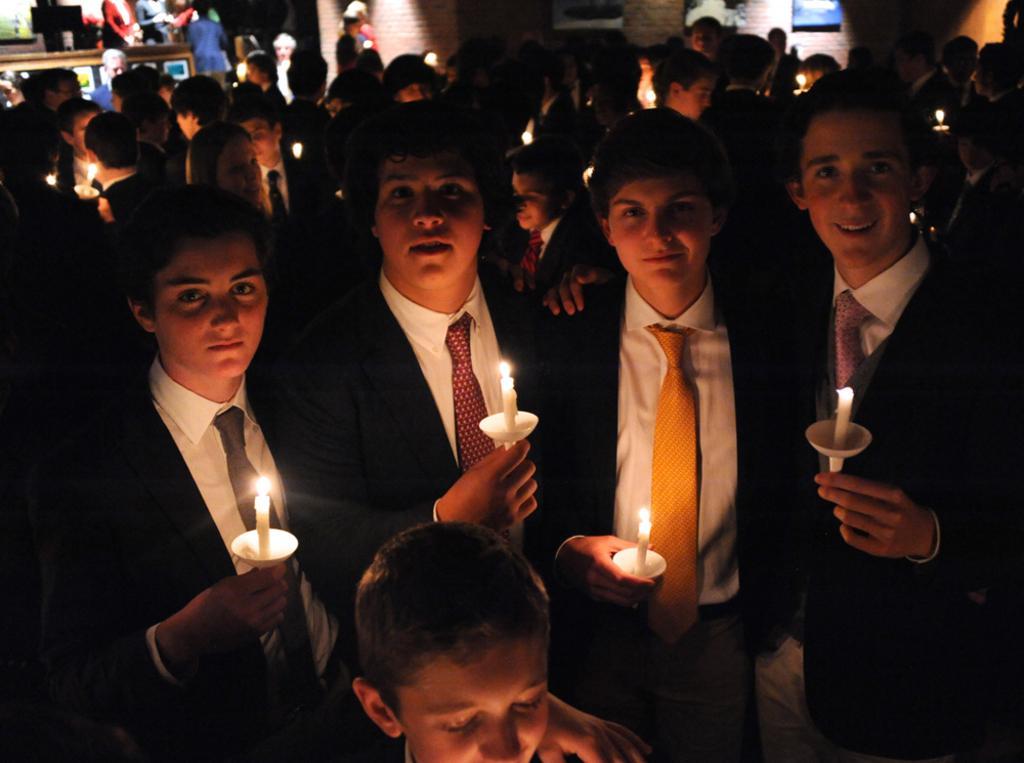Please provide a concise description of this image. In this picture, we see the people are standing and all of them are holding the candles in their hands. In front of the picture, we see a woman and three men are standing. They are holding the candles in their hands and they are posing for the photo. In the background, we see the people are standing. Behind them, we see a wall and we see the photo frames placed on the wall. In the left top, we see the people are standing. Behind them, we see a wall and a table. 